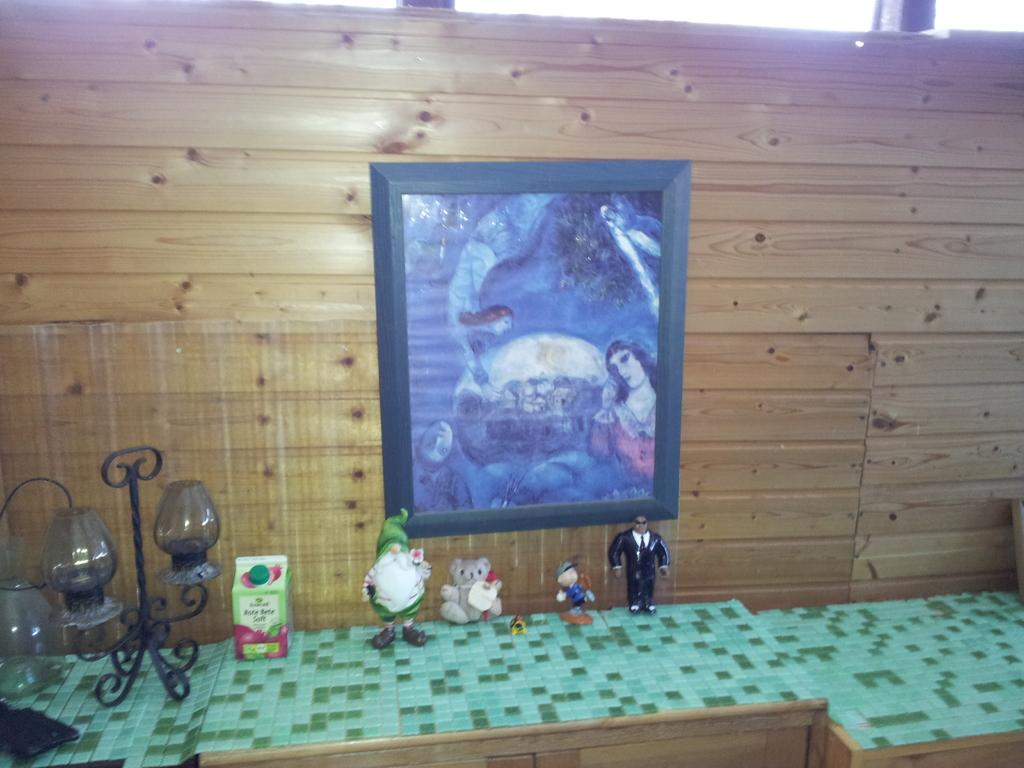What type of furniture is present in the image? There are wooden tables in the image. What is covering the wooden tables? The wooden tables have a green cover. What items can be seen on the green cover? There are toys and a lamp on the green cover. What can be seen in the background of the image? There is a wooden wall in the background. What is hanging on the wooden wall? There is a photo frame on the wooden wall. What scent is being emitted by the toys in the image? There is no information about the scent of the toys in the image, as the focus is on their appearance and location. 